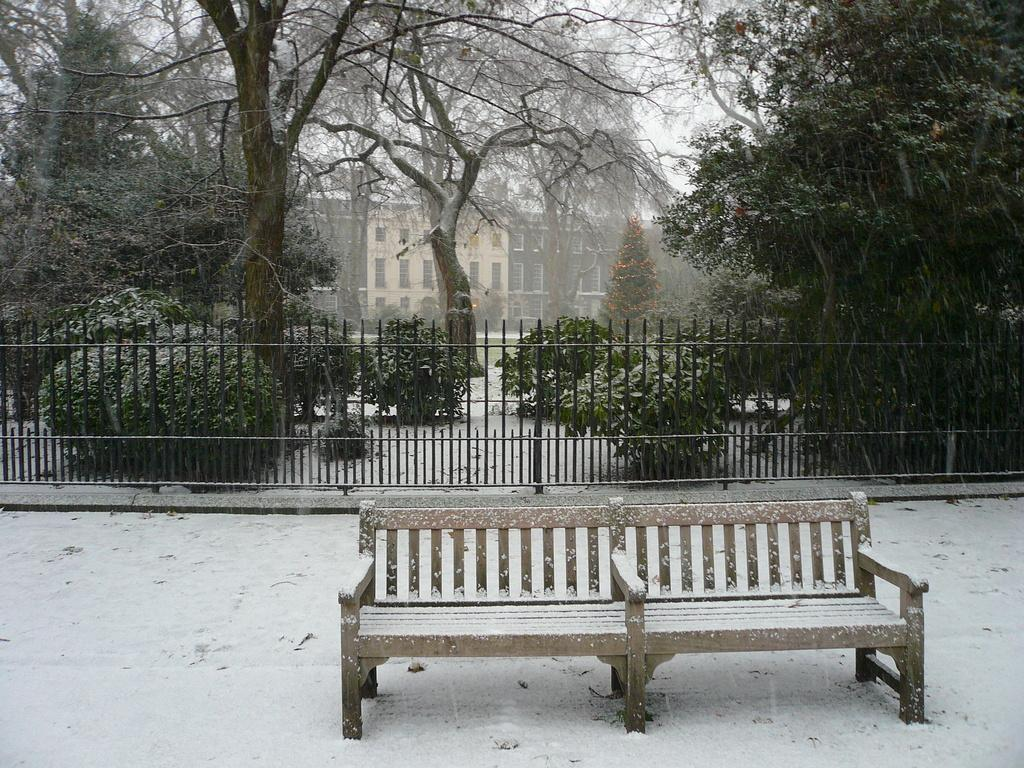What type of surface is visible in the image? There is a pavement in the image. What is located on the pavement? There is a bench on the pavement. What can be seen in the background of the image? There is a trailing plant, plants, trees, and buildings in the background of the image. What type of texture can be felt on the foot of the person walking in the image? There is no person walking in the image, so it is not possible to determine the texture of their foot. 